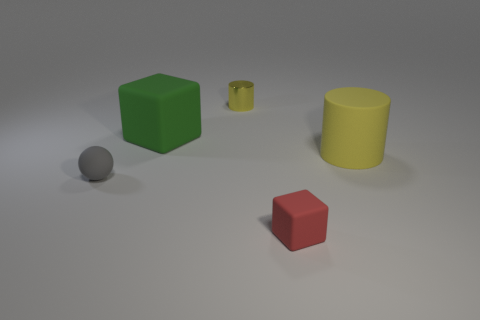There is another cylinder that is the same color as the small shiny cylinder; what material is it?
Your answer should be compact. Rubber. What number of tiny cyan rubber cylinders are there?
Ensure brevity in your answer.  0. Is the size of the rubber block left of the red thing the same as the tiny metallic cylinder?
Make the answer very short. No. How many metal objects are either blue objects or small blocks?
Give a very brief answer. 0. How many tiny gray matte objects are behind the tiny rubber thing that is on the left side of the big green object?
Make the answer very short. 0. There is a object that is behind the matte cylinder and in front of the small metal object; what shape is it?
Keep it short and to the point. Cube. What material is the cylinder that is to the left of the rubber block that is in front of the matte thing to the left of the large green rubber object made of?
Provide a succinct answer. Metal. What size is the rubber object that is the same color as the tiny cylinder?
Keep it short and to the point. Large. What is the material of the small cylinder?
Provide a short and direct response. Metal. Are the big block and the block that is in front of the big rubber cylinder made of the same material?
Provide a short and direct response. Yes. 